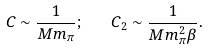<formula> <loc_0><loc_0><loc_500><loc_500>C \sim \frac { 1 } { M m _ { \pi } } ; \quad C _ { 2 } \sim \frac { 1 } { M m _ { \pi } ^ { 2 } \beta } .</formula> 